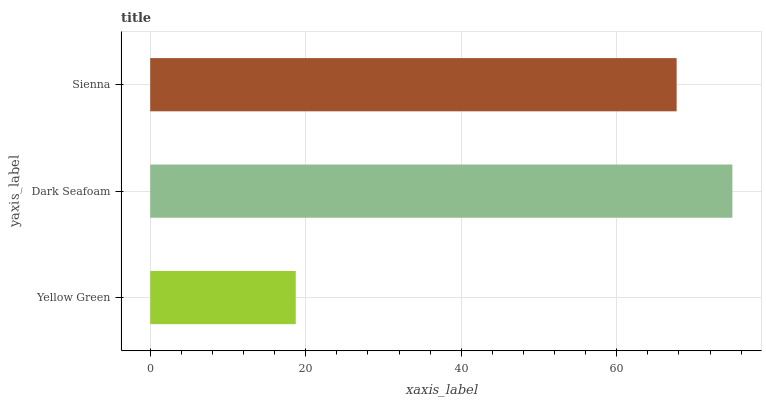Is Yellow Green the minimum?
Answer yes or no. Yes. Is Dark Seafoam the maximum?
Answer yes or no. Yes. Is Sienna the minimum?
Answer yes or no. No. Is Sienna the maximum?
Answer yes or no. No. Is Dark Seafoam greater than Sienna?
Answer yes or no. Yes. Is Sienna less than Dark Seafoam?
Answer yes or no. Yes. Is Sienna greater than Dark Seafoam?
Answer yes or no. No. Is Dark Seafoam less than Sienna?
Answer yes or no. No. Is Sienna the high median?
Answer yes or no. Yes. Is Sienna the low median?
Answer yes or no. Yes. Is Yellow Green the high median?
Answer yes or no. No. Is Dark Seafoam the low median?
Answer yes or no. No. 